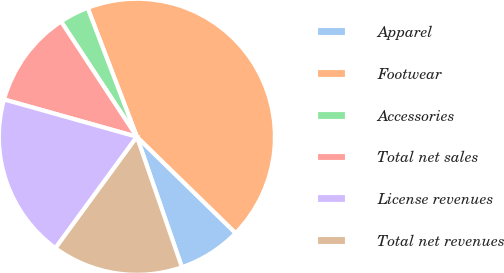Convert chart. <chart><loc_0><loc_0><loc_500><loc_500><pie_chart><fcel>Apparel<fcel>Footwear<fcel>Accessories<fcel>Total net sales<fcel>License revenues<fcel>Total net revenues<nl><fcel>7.41%<fcel>43.11%<fcel>3.45%<fcel>11.38%<fcel>19.31%<fcel>15.34%<nl></chart> 